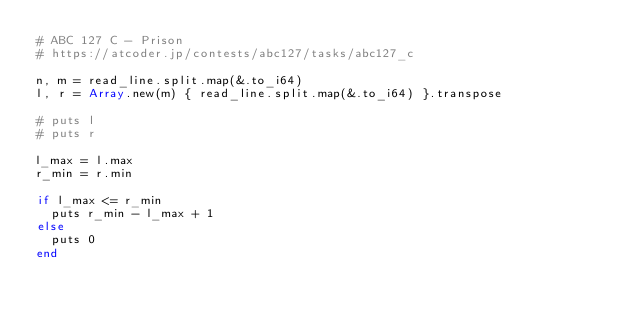<code> <loc_0><loc_0><loc_500><loc_500><_Crystal_># ABC 127 C - Prison
# https://atcoder.jp/contests/abc127/tasks/abc127_c

n, m = read_line.split.map(&.to_i64)
l, r = Array.new(m) { read_line.split.map(&.to_i64) }.transpose

# puts l
# puts r

l_max = l.max
r_min = r.min

if l_max <= r_min
  puts r_min - l_max + 1
else
  puts 0
end
</code> 